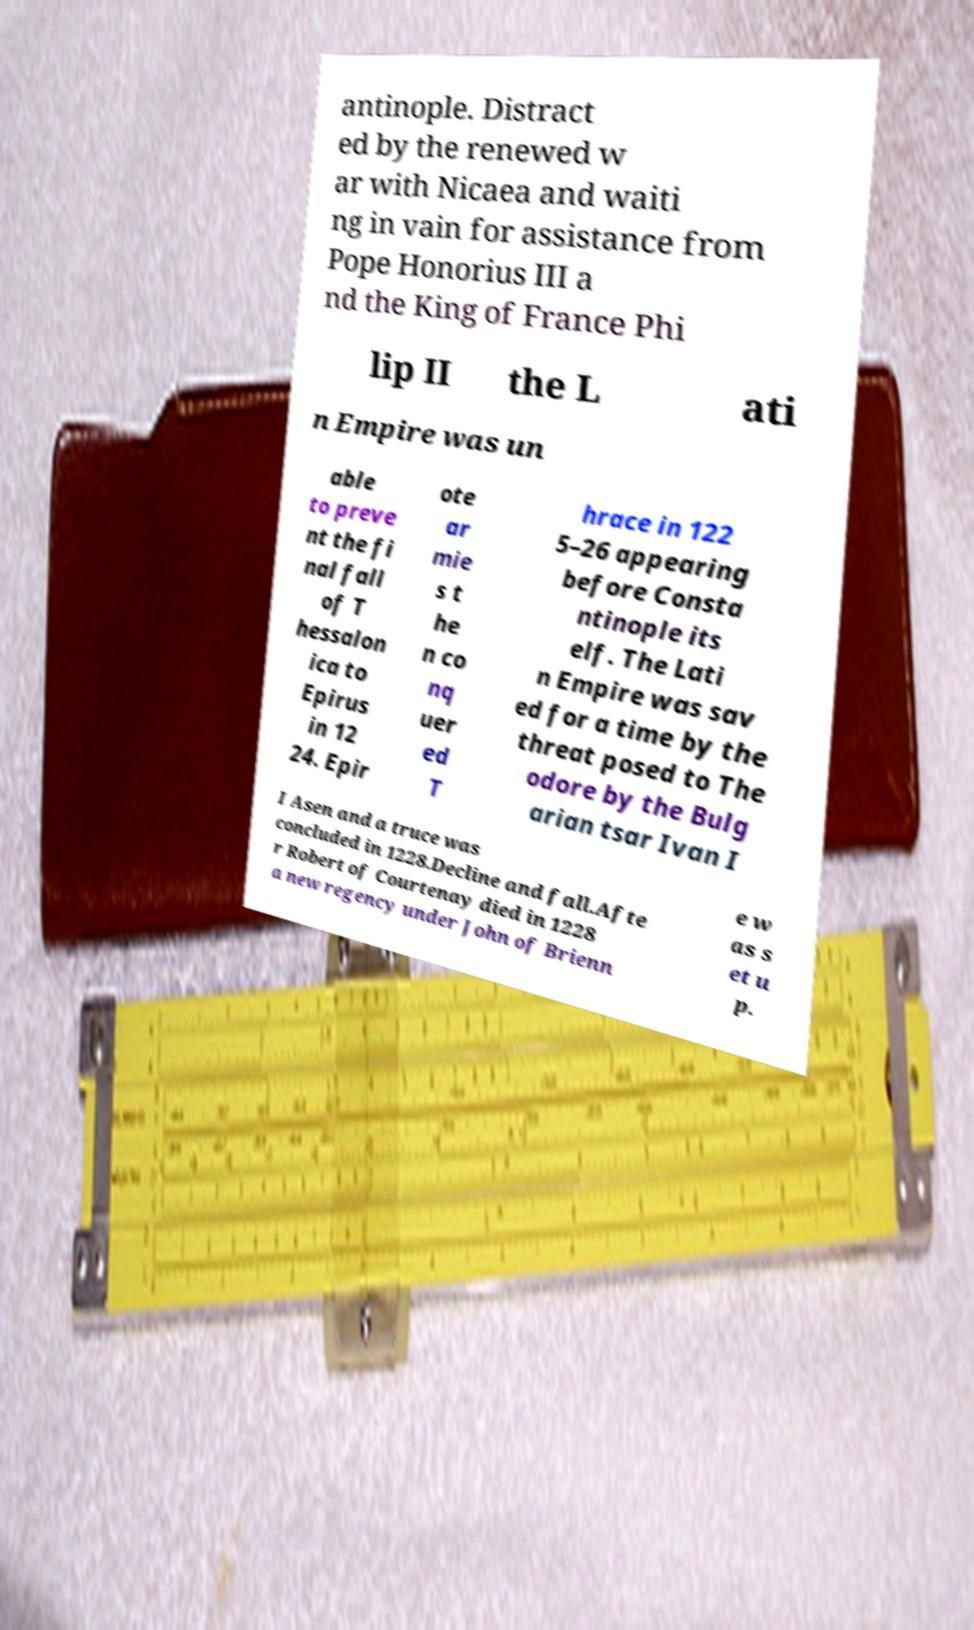I need the written content from this picture converted into text. Can you do that? antinople. Distract ed by the renewed w ar with Nicaea and waiti ng in vain for assistance from Pope Honorius III a nd the King of France Phi lip II the L ati n Empire was un able to preve nt the fi nal fall of T hessalon ica to Epirus in 12 24. Epir ote ar mie s t he n co nq uer ed T hrace in 122 5–26 appearing before Consta ntinople its elf. The Lati n Empire was sav ed for a time by the threat posed to The odore by the Bulg arian tsar Ivan I I Asen and a truce was concluded in 1228.Decline and fall.Afte r Robert of Courtenay died in 1228 a new regency under John of Brienn e w as s et u p. 